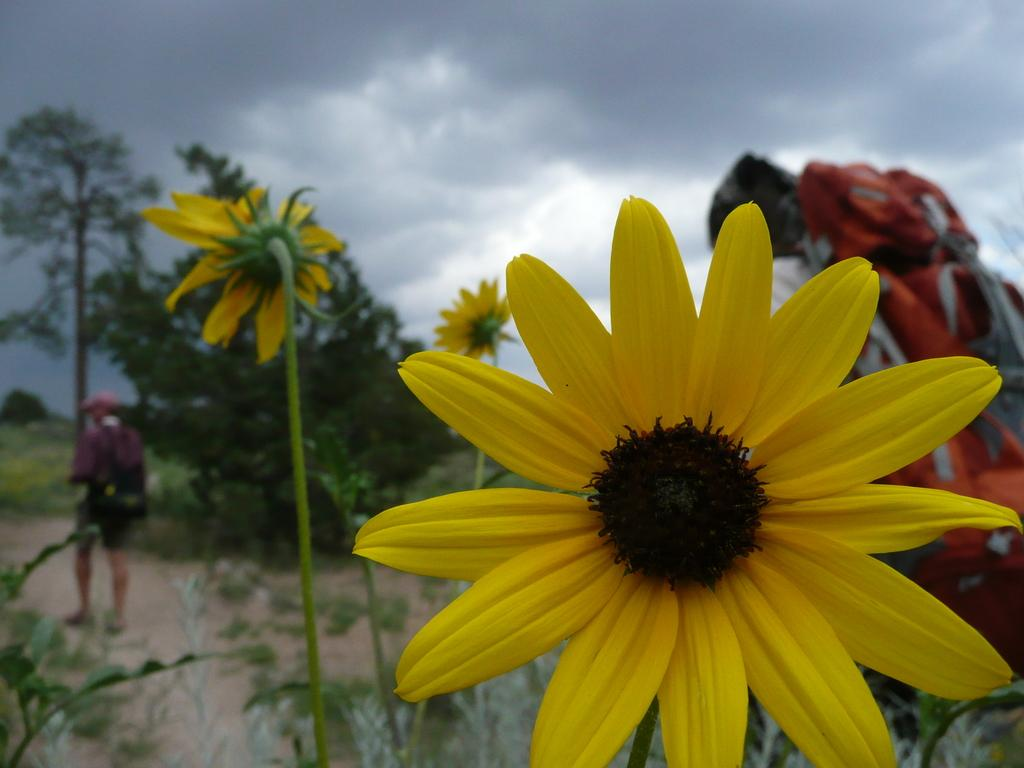What type of plant is in the image? There is a sunflower in the image. How many people are present in the image? There are two men in the image. What rule does the sunflower enforce in the image? There is no rule enforced by the sunflower in the image, as it is a plant and not capable of enforcing rules. 